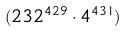<formula> <loc_0><loc_0><loc_500><loc_500>( 2 3 2 ^ { 4 2 9 } \cdot 4 ^ { 4 3 1 } )</formula> 